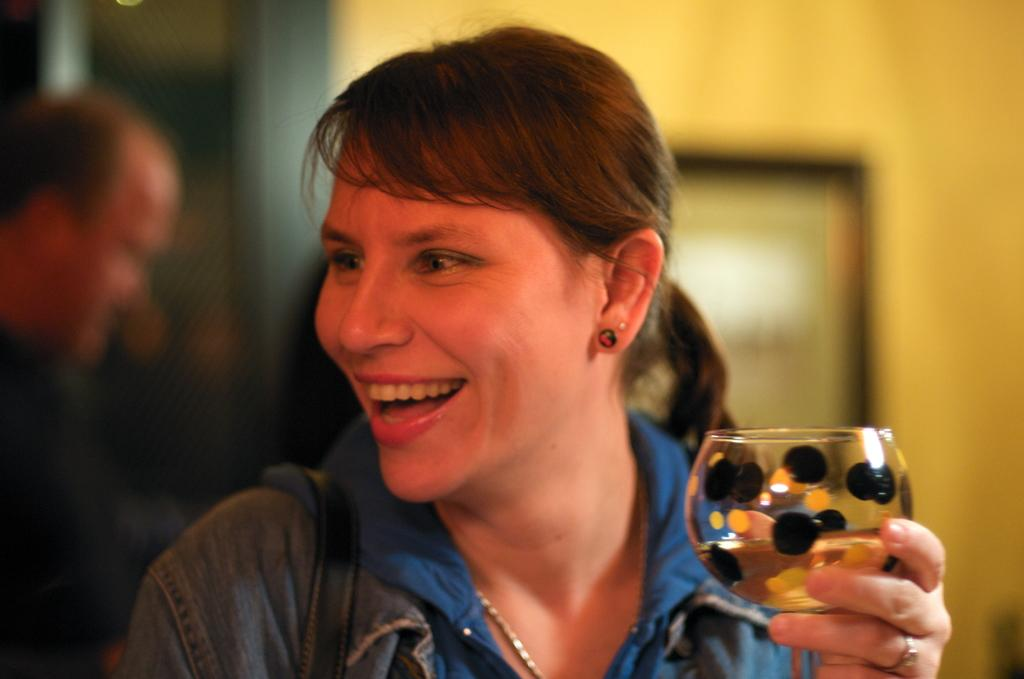Who is the main subject in the image? There is a woman in the image. What is the woman doing in the image? The woman is standing and smiling. What is the woman holding in her hand? The woman is holding a wine glass in her hand. Can you describe the person in the background of the image? There is a person standing in the background of the image. What year is depicted in the image? The image does not depict a specific year; it is a photograph of a woman and a person in the background. Who is the owner of the wine glass in the image? The image does not provide information about the ownership of the wine glass; it only shows the woman holding it. 